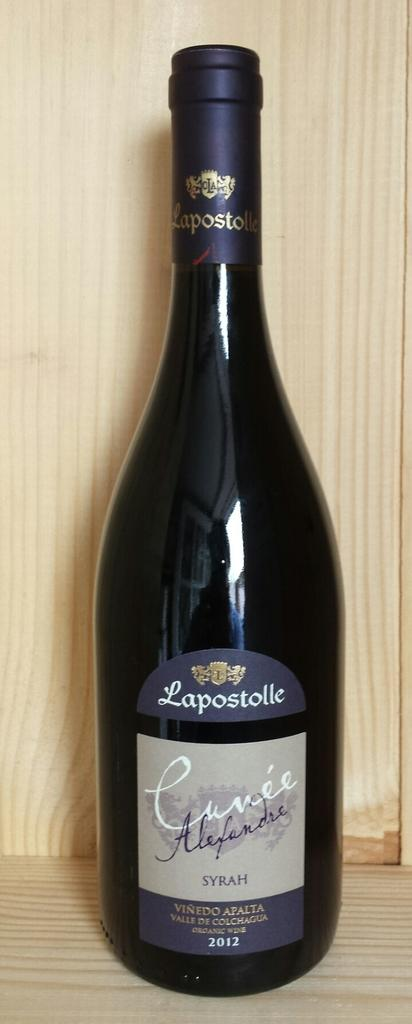<image>
Render a clear and concise summary of the photo. A wine bottle that is from Lapostolle vineyards. 